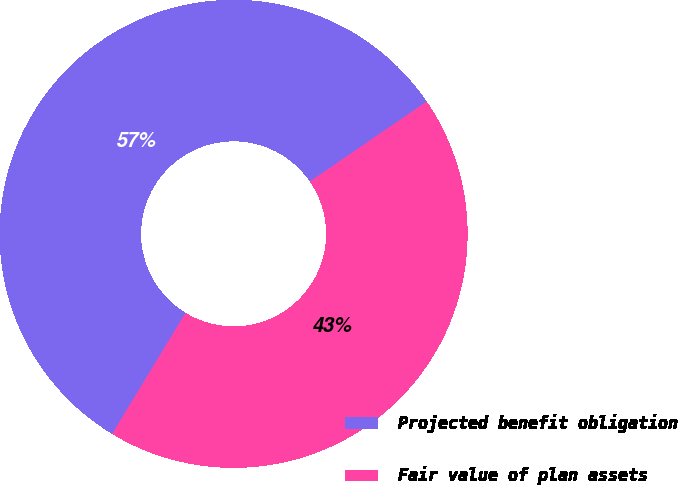Convert chart. <chart><loc_0><loc_0><loc_500><loc_500><pie_chart><fcel>Projected benefit obligation<fcel>Fair value of plan assets<nl><fcel>56.76%<fcel>43.24%<nl></chart> 